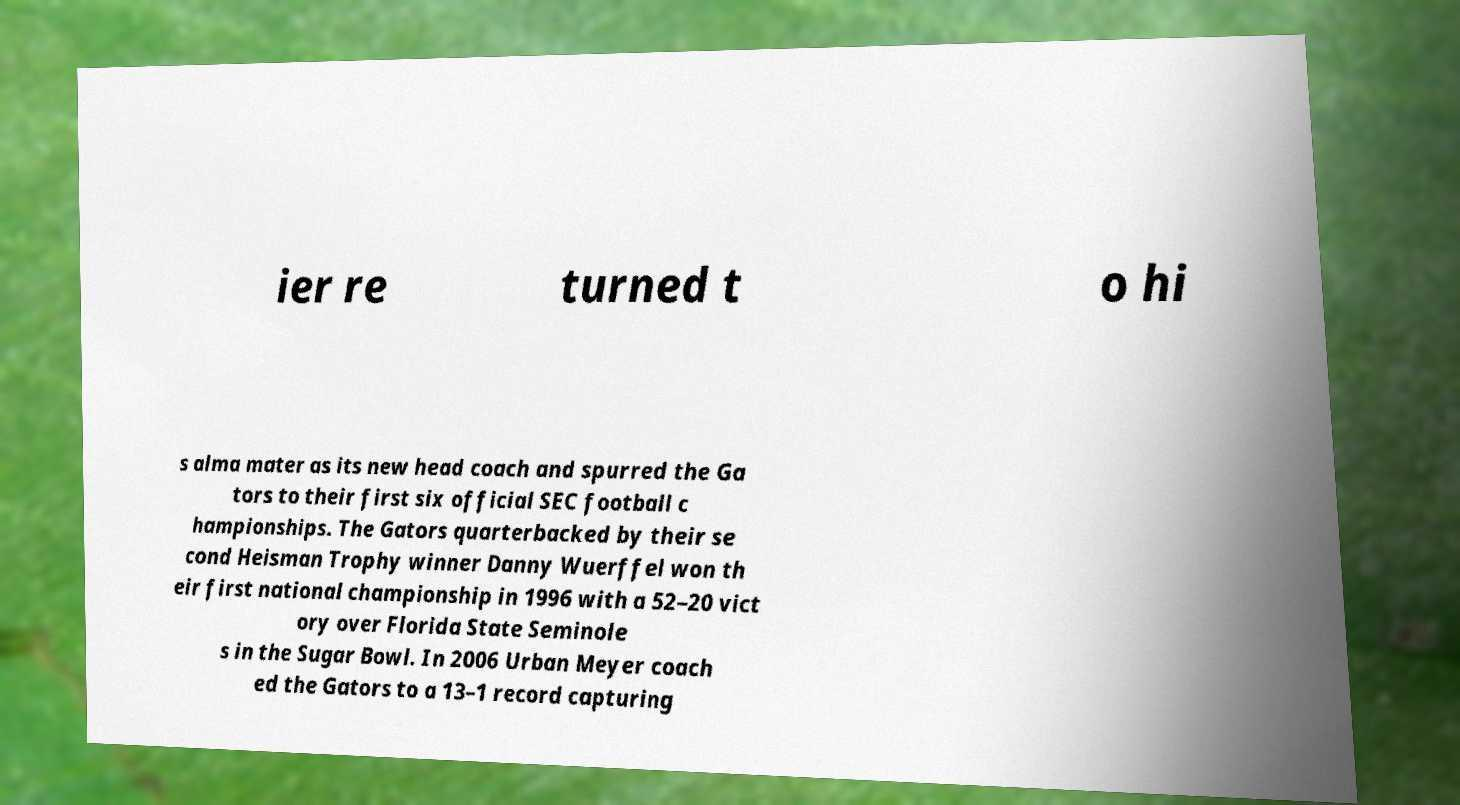Please identify and transcribe the text found in this image. ier re turned t o hi s alma mater as its new head coach and spurred the Ga tors to their first six official SEC football c hampionships. The Gators quarterbacked by their se cond Heisman Trophy winner Danny Wuerffel won th eir first national championship in 1996 with a 52–20 vict ory over Florida State Seminole s in the Sugar Bowl. In 2006 Urban Meyer coach ed the Gators to a 13–1 record capturing 